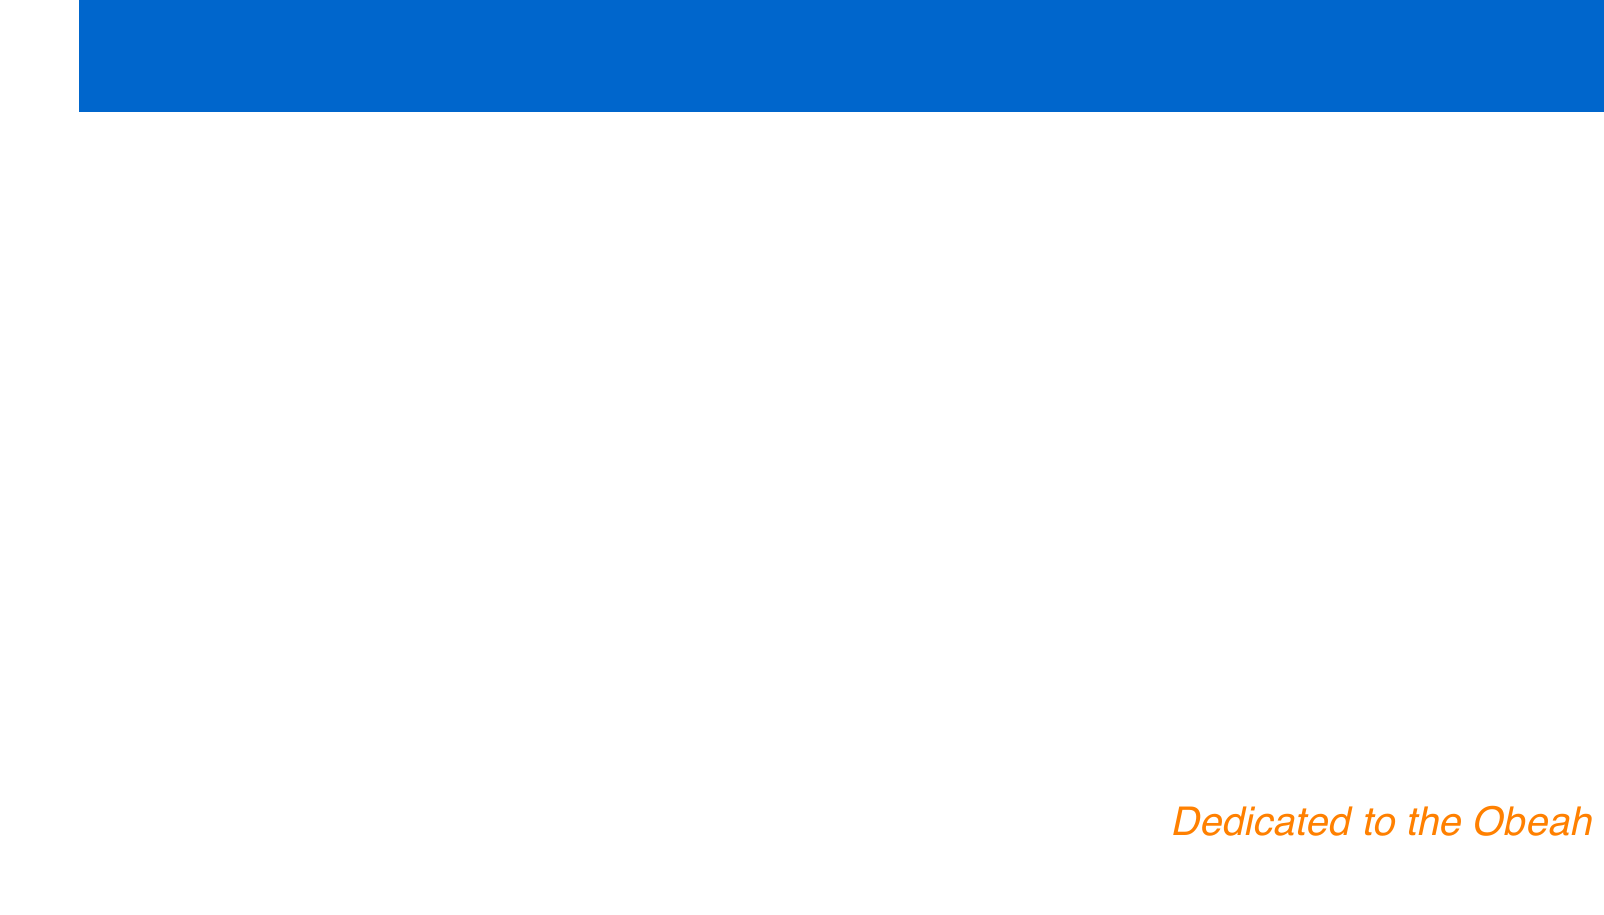what is the title of Exuma's first album? The document mentions 'Exuma I' as a notable album from 1970, which is his first studio album.
Answer: Exuma I how many rare pressings are identified in the agenda? The agenda specifically highlights two rare pressings: 'Do Wah Nanny' and 'Reincarnation'.
Answer: Two what year was 'Life' released? The document includes 'Life' in the context of missing albums and indicates it was released in 1973.
Answer: 1973 what is the purpose of networking with other collectors? The agenda states that networking is intended to connect with other collectors to potentially locate missing albums.
Answer: Locate missing albums which album is associated with the highest potential cost? The agenda highlights 'Exuma, The Obeah Man', noting its potential high costs among sought-after releases.
Answer: Exuma, The Obeah Man how many main tasks are listed in the agenda? The document outlines ten distinct tasks related to tracking the progress of the Exuma vinyl collection.
Answer: Ten what is the proposed fund for? The agenda suggests setting up a dedicated fund specifically for purchasing rare Exuma albums.
Answer: Purchasing rare Exuma albums what type of condition assessment is mentioned? The agenda mentions developing a grading system for evaluating the condition of Exuma vinyl records.
Answer: Grading system 